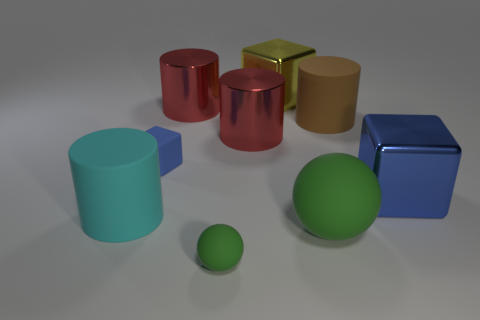Subtract all cyan cylinders. How many cylinders are left? 3 Subtract all green cylinders. How many blue cubes are left? 2 Subtract 2 cubes. How many cubes are left? 1 Add 1 small red metal cubes. How many objects exist? 10 Subtract all yellow cubes. How many cubes are left? 2 Subtract all cubes. How many objects are left? 6 Subtract all cyan balls. Subtract all gray cylinders. How many balls are left? 2 Subtract all red things. Subtract all large brown rubber cylinders. How many objects are left? 6 Add 7 big rubber cylinders. How many big rubber cylinders are left? 9 Add 6 big shiny cubes. How many big shiny cubes exist? 8 